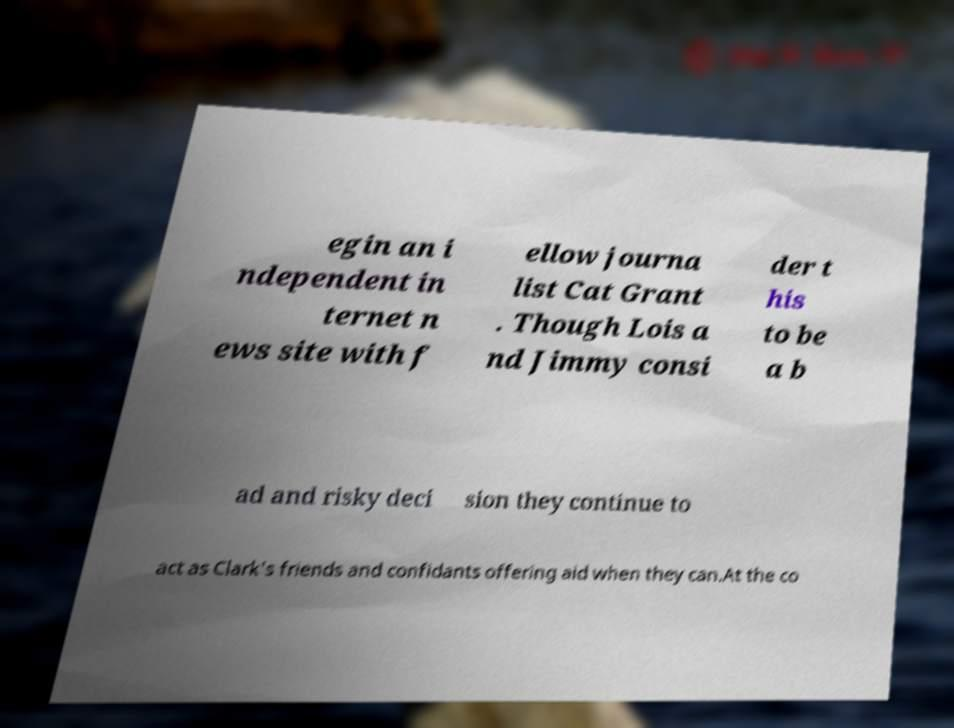For documentation purposes, I need the text within this image transcribed. Could you provide that? egin an i ndependent in ternet n ews site with f ellow journa list Cat Grant . Though Lois a nd Jimmy consi der t his to be a b ad and risky deci sion they continue to act as Clark's friends and confidants offering aid when they can.At the co 